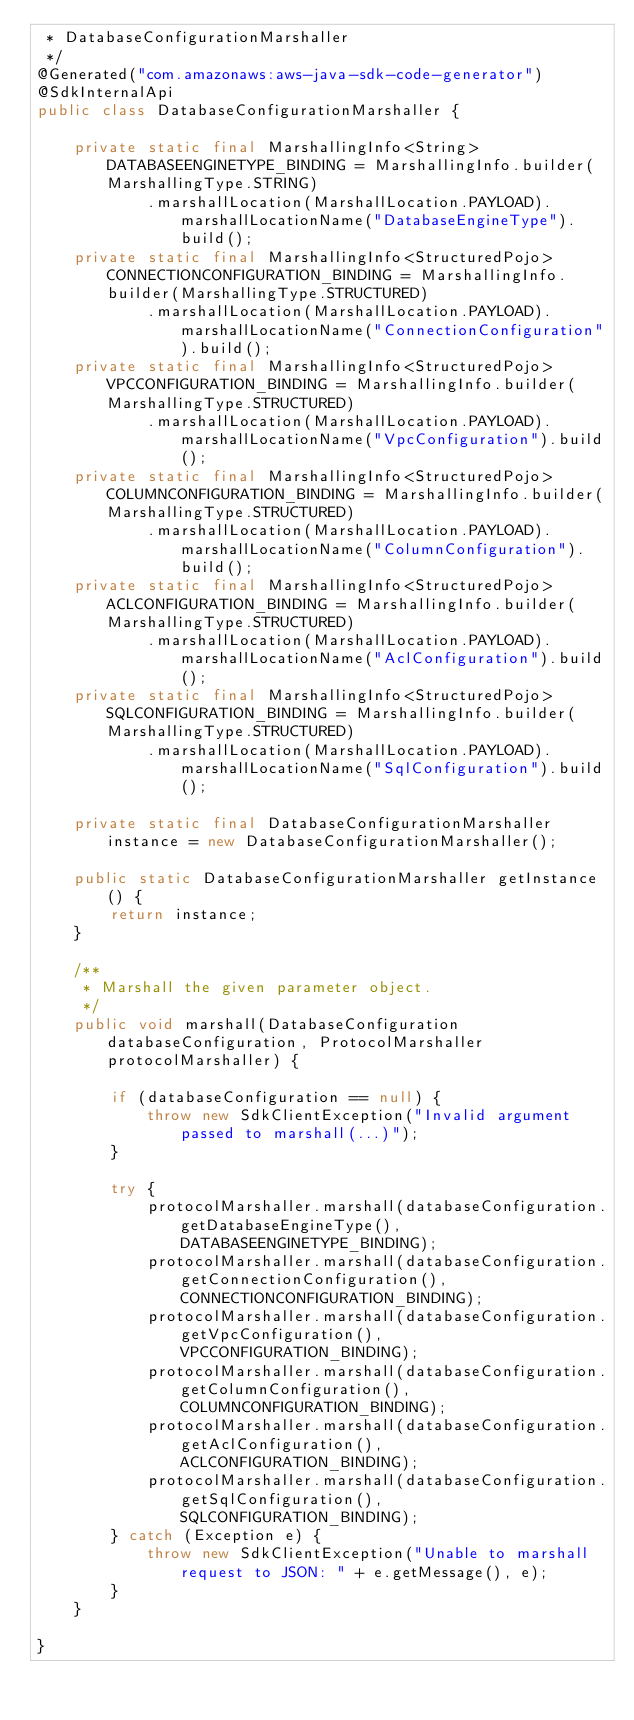<code> <loc_0><loc_0><loc_500><loc_500><_Java_> * DatabaseConfigurationMarshaller
 */
@Generated("com.amazonaws:aws-java-sdk-code-generator")
@SdkInternalApi
public class DatabaseConfigurationMarshaller {

    private static final MarshallingInfo<String> DATABASEENGINETYPE_BINDING = MarshallingInfo.builder(MarshallingType.STRING)
            .marshallLocation(MarshallLocation.PAYLOAD).marshallLocationName("DatabaseEngineType").build();
    private static final MarshallingInfo<StructuredPojo> CONNECTIONCONFIGURATION_BINDING = MarshallingInfo.builder(MarshallingType.STRUCTURED)
            .marshallLocation(MarshallLocation.PAYLOAD).marshallLocationName("ConnectionConfiguration").build();
    private static final MarshallingInfo<StructuredPojo> VPCCONFIGURATION_BINDING = MarshallingInfo.builder(MarshallingType.STRUCTURED)
            .marshallLocation(MarshallLocation.PAYLOAD).marshallLocationName("VpcConfiguration").build();
    private static final MarshallingInfo<StructuredPojo> COLUMNCONFIGURATION_BINDING = MarshallingInfo.builder(MarshallingType.STRUCTURED)
            .marshallLocation(MarshallLocation.PAYLOAD).marshallLocationName("ColumnConfiguration").build();
    private static final MarshallingInfo<StructuredPojo> ACLCONFIGURATION_BINDING = MarshallingInfo.builder(MarshallingType.STRUCTURED)
            .marshallLocation(MarshallLocation.PAYLOAD).marshallLocationName("AclConfiguration").build();
    private static final MarshallingInfo<StructuredPojo> SQLCONFIGURATION_BINDING = MarshallingInfo.builder(MarshallingType.STRUCTURED)
            .marshallLocation(MarshallLocation.PAYLOAD).marshallLocationName("SqlConfiguration").build();

    private static final DatabaseConfigurationMarshaller instance = new DatabaseConfigurationMarshaller();

    public static DatabaseConfigurationMarshaller getInstance() {
        return instance;
    }

    /**
     * Marshall the given parameter object.
     */
    public void marshall(DatabaseConfiguration databaseConfiguration, ProtocolMarshaller protocolMarshaller) {

        if (databaseConfiguration == null) {
            throw new SdkClientException("Invalid argument passed to marshall(...)");
        }

        try {
            protocolMarshaller.marshall(databaseConfiguration.getDatabaseEngineType(), DATABASEENGINETYPE_BINDING);
            protocolMarshaller.marshall(databaseConfiguration.getConnectionConfiguration(), CONNECTIONCONFIGURATION_BINDING);
            protocolMarshaller.marshall(databaseConfiguration.getVpcConfiguration(), VPCCONFIGURATION_BINDING);
            protocolMarshaller.marshall(databaseConfiguration.getColumnConfiguration(), COLUMNCONFIGURATION_BINDING);
            protocolMarshaller.marshall(databaseConfiguration.getAclConfiguration(), ACLCONFIGURATION_BINDING);
            protocolMarshaller.marshall(databaseConfiguration.getSqlConfiguration(), SQLCONFIGURATION_BINDING);
        } catch (Exception e) {
            throw new SdkClientException("Unable to marshall request to JSON: " + e.getMessage(), e);
        }
    }

}
</code> 